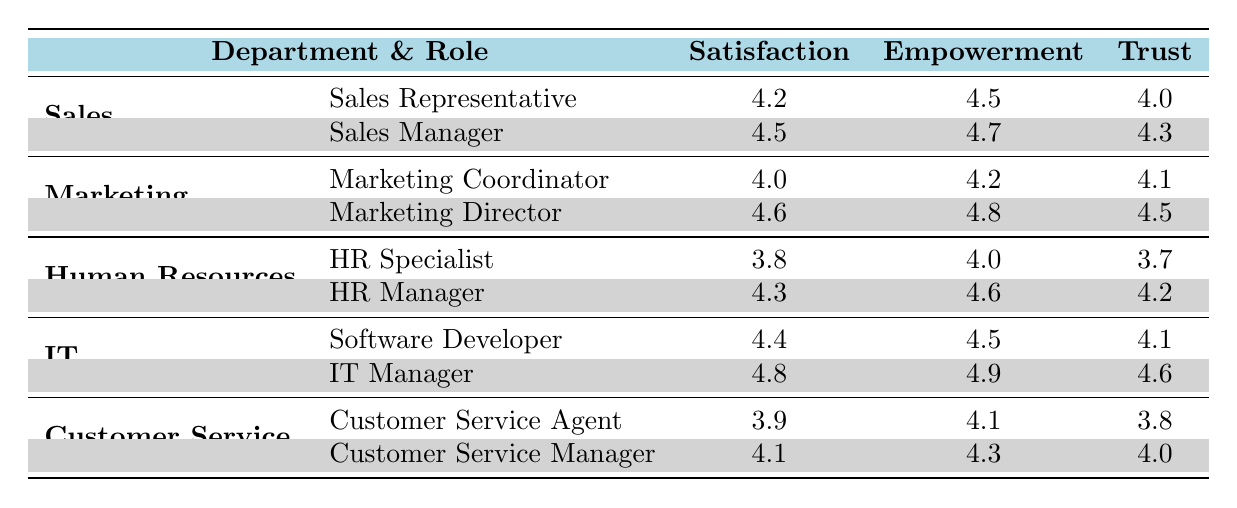What is the highest satisfaction score among all departments? The satisfaction scores for each department are: Sales (4.2, 4.5), Marketing (4.0, 4.6), Human Resources (3.8, 4.3), IT (4.4, 4.8), and Customer Service (3.9, 4.1). The highest score is 4.8 from the IT Manager in the IT department.
Answer: 4.8 Which role in the Marketing department has the highest trust rating? The trust ratings in the Marketing department are: Marketing Coordinator (4.1), Marketing Director (4.5). The highest trust rating is 4.5, which belongs to the Marketing Director.
Answer: Marketing Director What is the average empowerment rating across all roles in the IT department? The empowerment ratings for the IT department are: Software Developer (4.5) and IT Manager (4.9). The average is (4.5 + 4.9) / 2 = 4.7.
Answer: 4.7 Is the satisfaction score for HR Specialist higher than that of Customer Service Agent? The satisfaction scores are HR Specialist (3.8) and Customer Service Agent (3.9). Since 3.8 is less than 3.9, this statement is false.
Answer: No Which department has the lowest average satisfaction score, and what is that score? The satisfaction scores are: Sales (4.2, 4.5), Marketing (4.0, 4.6), Human Resources (3.8, 4.3), IT (4.4, 4.8), Customer Service (3.9, 4.1). The averages are: Sales (4.35), Marketing (4.3), Human Resources (4.05), IT (4.6), Customer Service (4.0). The lowest average is for Human Resources at 4.05.
Answer: Human Resources, 4.05 What is the difference in empowerment ratings between the Sales Manager and HR Manager? The empowerment ratings are: Sales Manager (4.7) and HR Manager (4.6). The difference is 4.7 - 4.6 = 0.1.
Answer: 0.1 